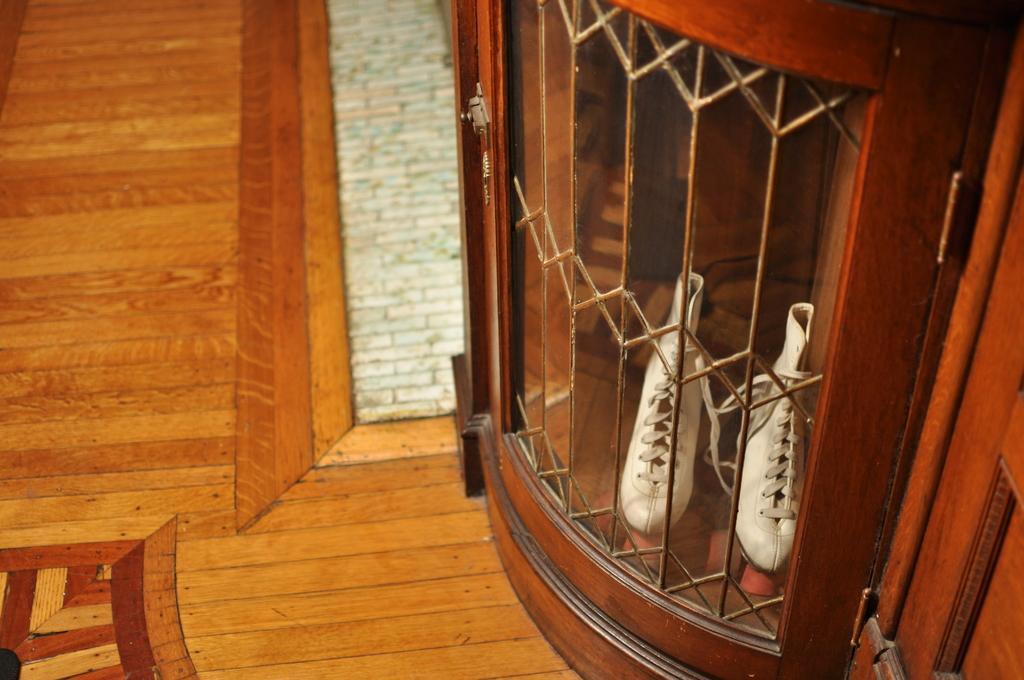Please provide a concise description of this image. In the image I can see a pair of white shoe which are in the cupboard. 